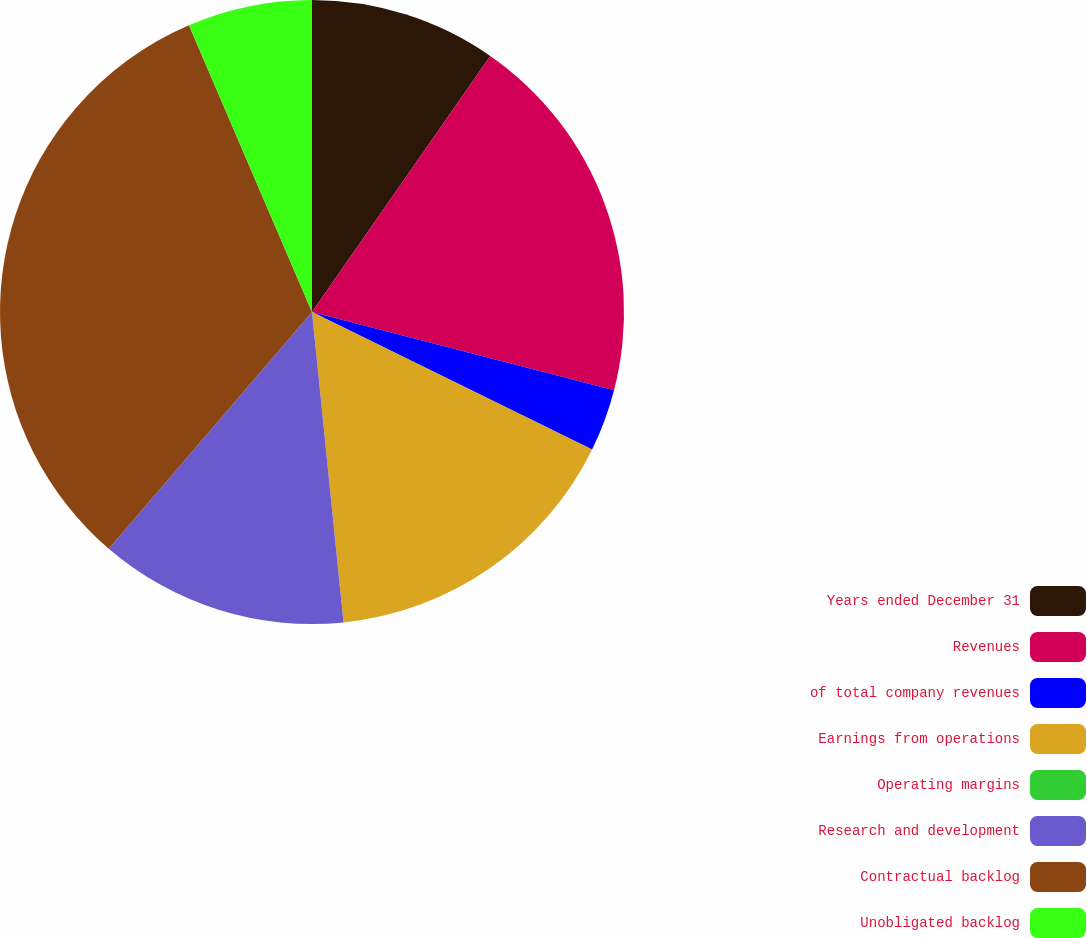Convert chart. <chart><loc_0><loc_0><loc_500><loc_500><pie_chart><fcel>Years ended December 31<fcel>Revenues<fcel>of total company revenues<fcel>Earnings from operations<fcel>Operating margins<fcel>Research and development<fcel>Contractual backlog<fcel>Unobligated backlog<nl><fcel>9.68%<fcel>19.35%<fcel>3.23%<fcel>16.13%<fcel>0.0%<fcel>12.9%<fcel>32.26%<fcel>6.45%<nl></chart> 